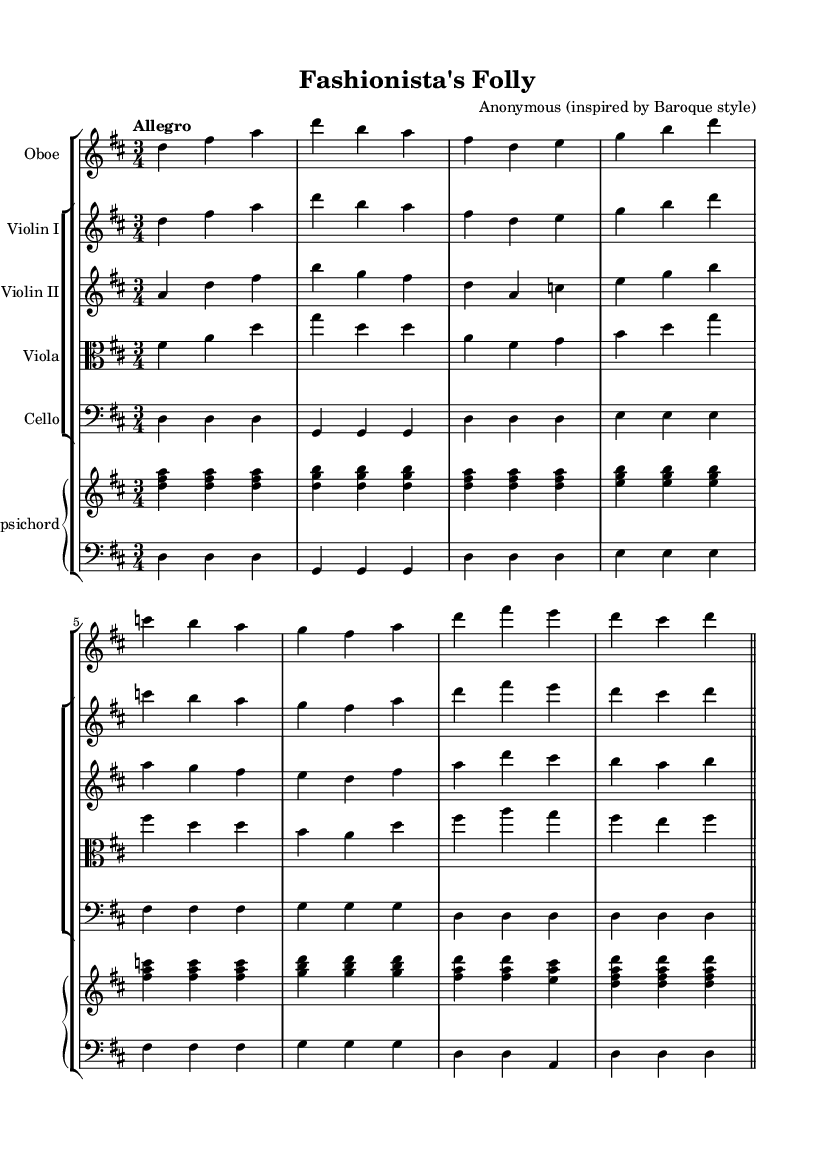What is the key signature of this music? The key signature is D major, which has two sharps (F# and C#). This can be determined by looking at the key signature at the beginning of the staff where two sharp symbols are placed on the F and C lines.
Answer: D major What is the time signature of this music? The time signature is 3/4, indicated by the "3/4" notation found at the beginning of the score. This means there are three beats in each measure and the quarter note receives one beat.
Answer: 3/4 What is the tempo marking for this piece? The tempo marking is "Allegro," which is indicated above the staff. "Allegro" typically suggests a lively and upbeat pace, usually around 120-168 beats per minute.
Answer: Allegro How many measures are in the piece? The piece consists of 16 measures. By counting each group of musical notation delineated by the bar lines (both double and single), the total number of measures is established.
Answer: 16 What instruments are featured in this music? The featured instruments include the oboe, two violins, viola, cello, and harpsichord. This can be observed from the labeled staves at the beginning of the score, where each instrument is named accordingly.
Answer: Oboe, Violin I, Violin II, Viola, Cello, Harpsichord What dance suite style is represented in this music? The music represents an upbeat Baroque dance style, which is a common characteristic of dance suites from the Baroque period. The lively tempo and structured rhythmic quality suggest a common style used during that era for dances.
Answer: Baroque dance 